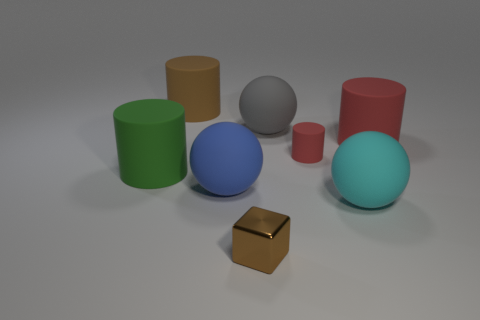Can you compare the relative sizes of the objects in the image? Certainly, the blue sphere appears to be the largest object, followed by the green and red cylinders. The cyan sphere and the grey sphere are smaller, and the smallest objects seem to be the brown block and the small cylinder next to it. 